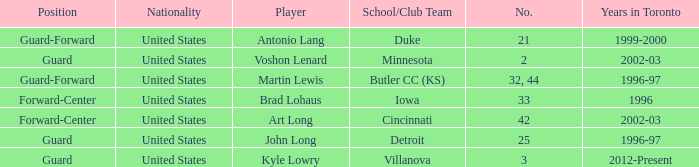What school did player number 21 play for? Duke. 